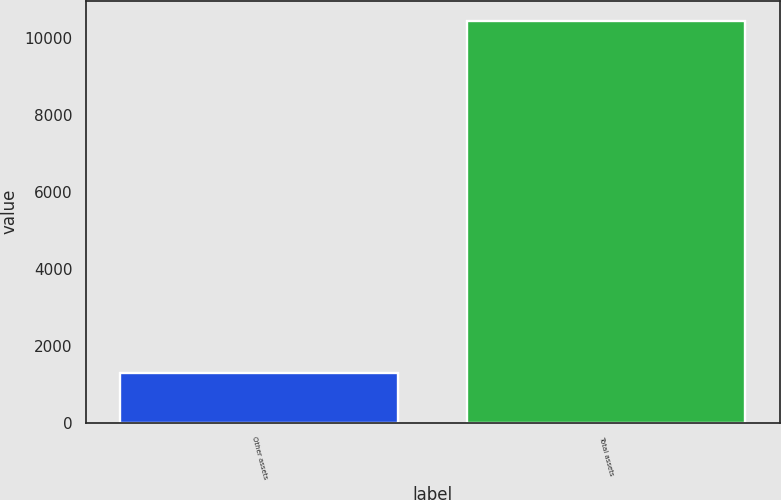Convert chart to OTSL. <chart><loc_0><loc_0><loc_500><loc_500><bar_chart><fcel>Other assets<fcel>Total assets<nl><fcel>1281<fcel>10435<nl></chart> 